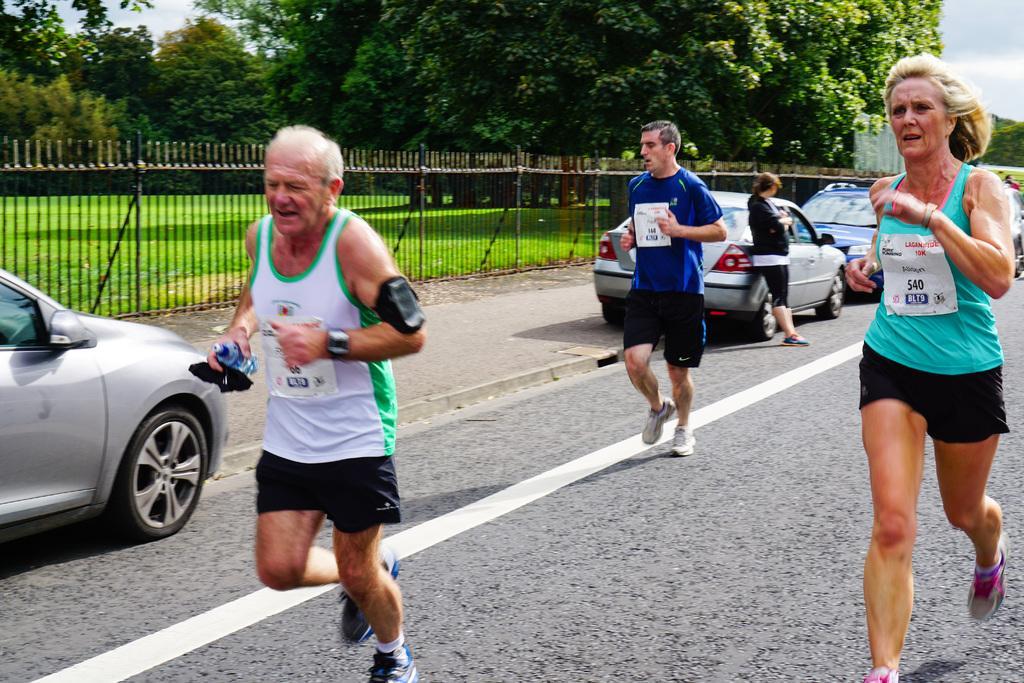In one or two sentences, can you explain what this image depicts? In this image, we can see three people are running on the road. Here we can see few vehicles are parked. On the right side of the image, we can see a woman is standing. Background we can see fencing, grass, trees and sky. 